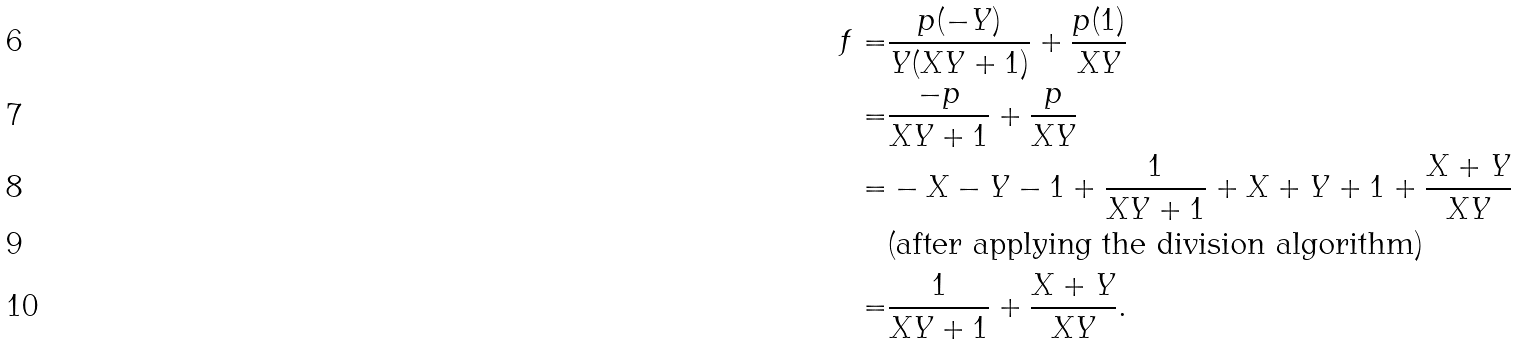<formula> <loc_0><loc_0><loc_500><loc_500>f = & \frac { p ( - Y ) } { Y ( X Y + 1 ) } + \frac { p ( 1 ) } { X Y } \\ = & \frac { - p } { X Y + 1 } + \frac { p } { X Y } \\ = & - X - Y - 1 + \frac { 1 } { X Y + 1 } + X + Y + 1 + \frac { X + Y } { X Y } \\ & \text {(after applying the division algorithm)} \\ = & \frac { 1 } { X Y + 1 } + \frac { X + Y } { X Y } .</formula> 